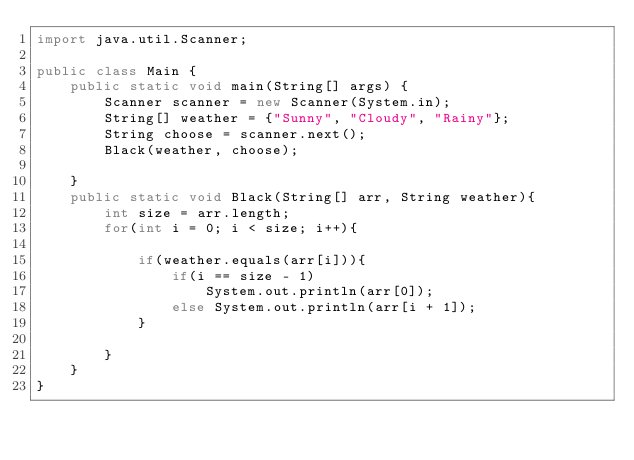<code> <loc_0><loc_0><loc_500><loc_500><_Java_>import java.util.Scanner;

public class Main {
    public static void main(String[] args) {
        Scanner scanner = new Scanner(System.in);
        String[] weather = {"Sunny", "Cloudy", "Rainy"};
        String choose = scanner.next();
        Black(weather, choose);

    }
    public static void Black(String[] arr, String weather){
        int size = arr.length;
        for(int i = 0; i < size; i++){

            if(weather.equals(arr[i])){
                if(i == size - 1)
                    System.out.println(arr[0]);
                else System.out.println(arr[i + 1]);
            }

        }
    }
}</code> 